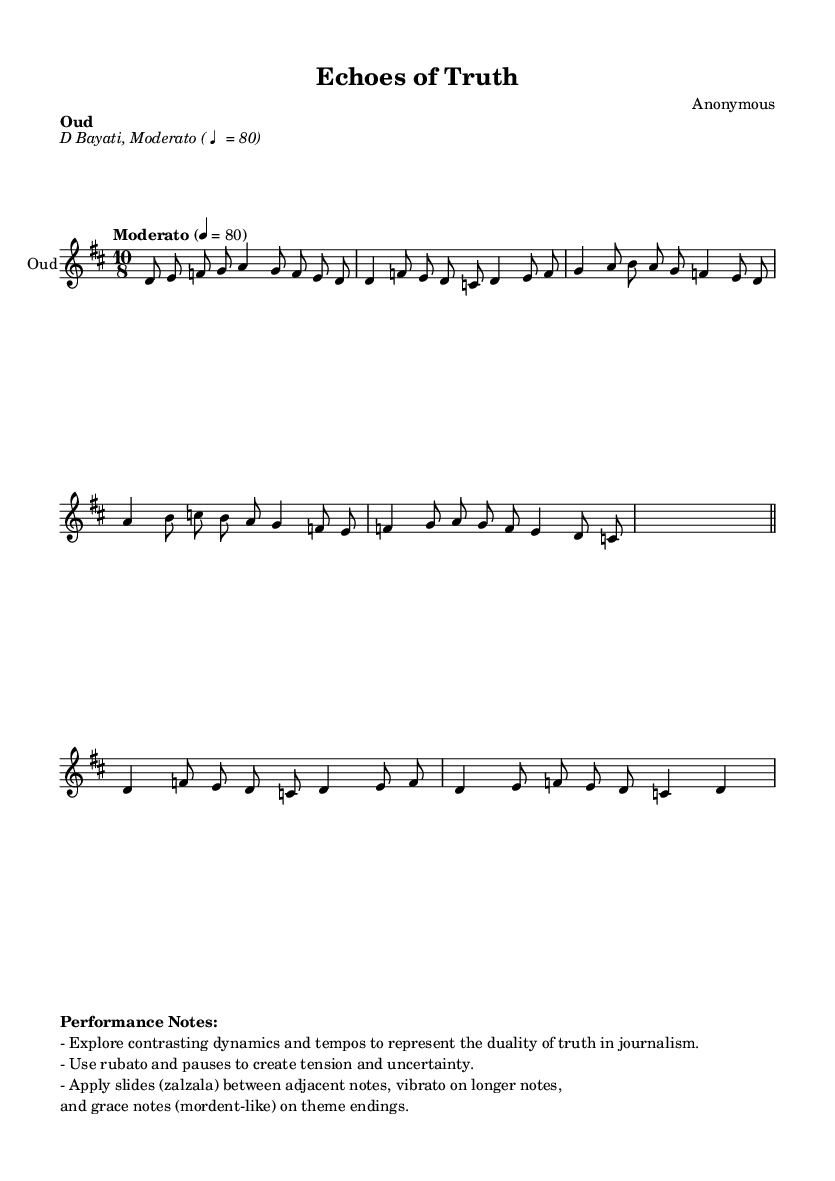What is the key signature of this music? The key signature is D major, which has two sharps (F# and C#). This is indicated at the beginning of the score.
Answer: D major What is the time signature of this composition? The time signature is 10/8, which means there are ten eighth notes per measure. This is stated at the beginning of the music.
Answer: 10/8 What is the tempo marking for the piece? The tempo marking is Moderato, which indicates a moderate speed. The specific metronome marking is given as ♩ = 80.
Answer: Moderato Which section contains improvisation? The section labeled with the placeholder for improvisation is identified by the cadenza notation, where there are silent measures marked to indicate freedom in performance.
Answer: Improvisation section How do the dynamics reflect the duality of truth in journalism? The performance notes suggest exploring contrasting dynamics and tempos to express tension and uncertainty, which symbolize the conflicting nature of truth in journalism.
Answer: Contrasting dynamics What rhythm is used in the primary themes of this composition? The rhythm primarily features a combination of quarter notes and eighth notes, creating a flowing yet intricate melodic line, particularly evident in Themes A and B.
Answer: Quarter and eighth notes What is the function of the zalzala in this piece? The zalzala (slides) are meant to add expressiveness and a sense of fluidity to the melody, enhancing the emotional texture as depicted in the performance notes.
Answer: Expressiveness 